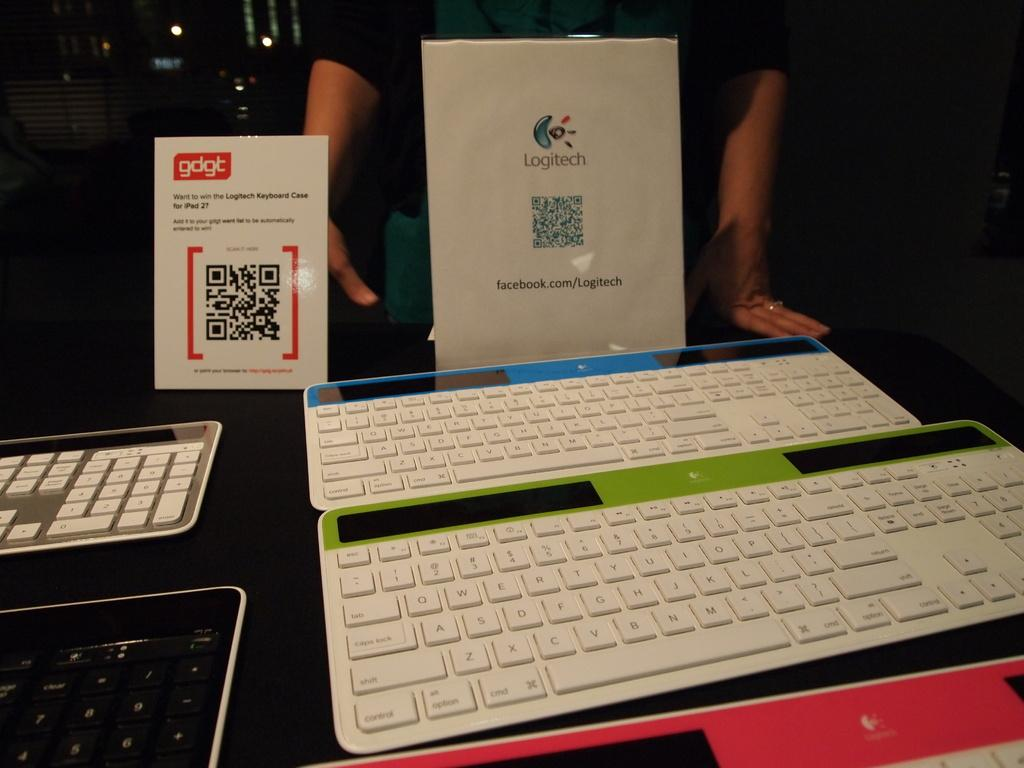<image>
Give a short and clear explanation of the subsequent image. A display of keyboards in front of a Logitech sign 